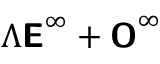Convert formula to latex. <formula><loc_0><loc_0><loc_500><loc_500>\Lambda E ^ { \infty } + O ^ { \infty }</formula> 